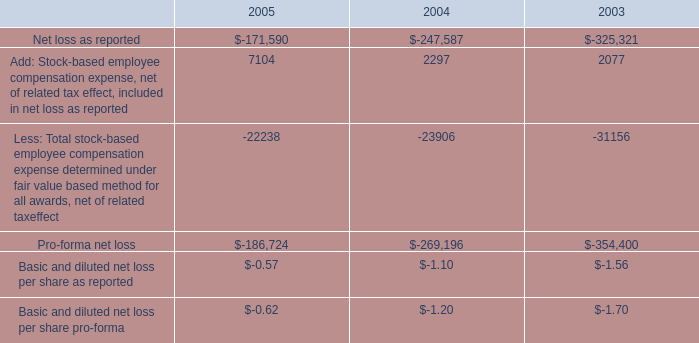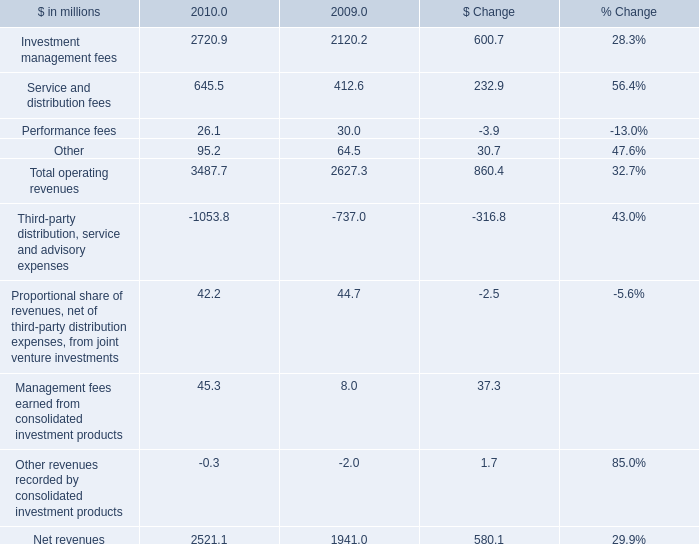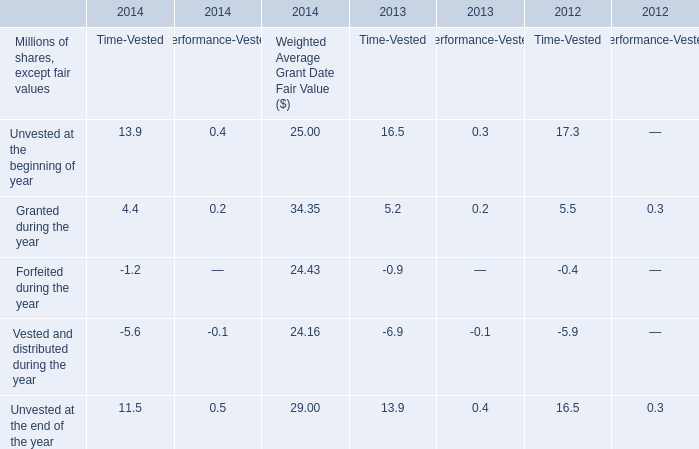What is the proportion of Investment management fees to the total in 2010? 
Computations: (2720.9 / 2521.1)
Answer: 1.07925. 